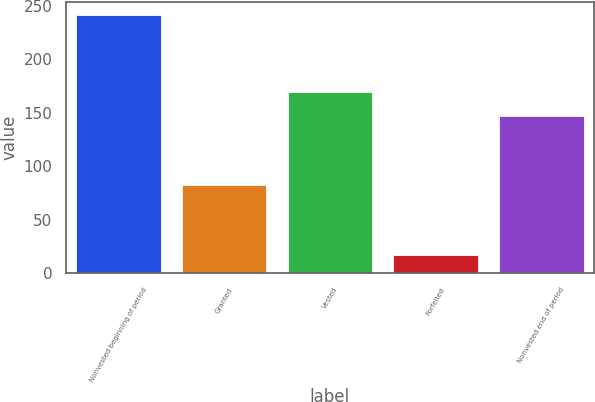Convert chart. <chart><loc_0><loc_0><loc_500><loc_500><bar_chart><fcel>Nonvested beginning of period<fcel>Granted<fcel>Vested<fcel>Forfeited<fcel>Nonvested end of period<nl><fcel>242<fcel>83<fcel>169.5<fcel>17<fcel>147<nl></chart> 